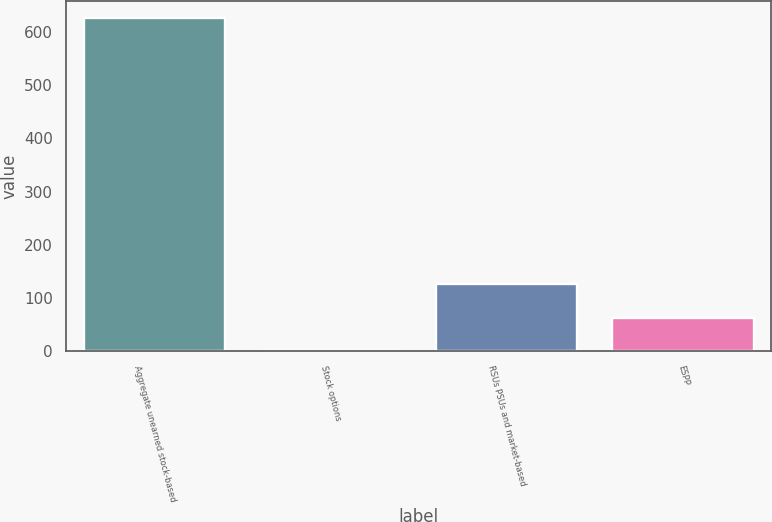Convert chart. <chart><loc_0><loc_0><loc_500><loc_500><bar_chart><fcel>Aggregate unearned stock-based<fcel>Stock options<fcel>RSUs PSUs and market-based<fcel>ESPP<nl><fcel>627<fcel>0.5<fcel>125.8<fcel>63.15<nl></chart> 